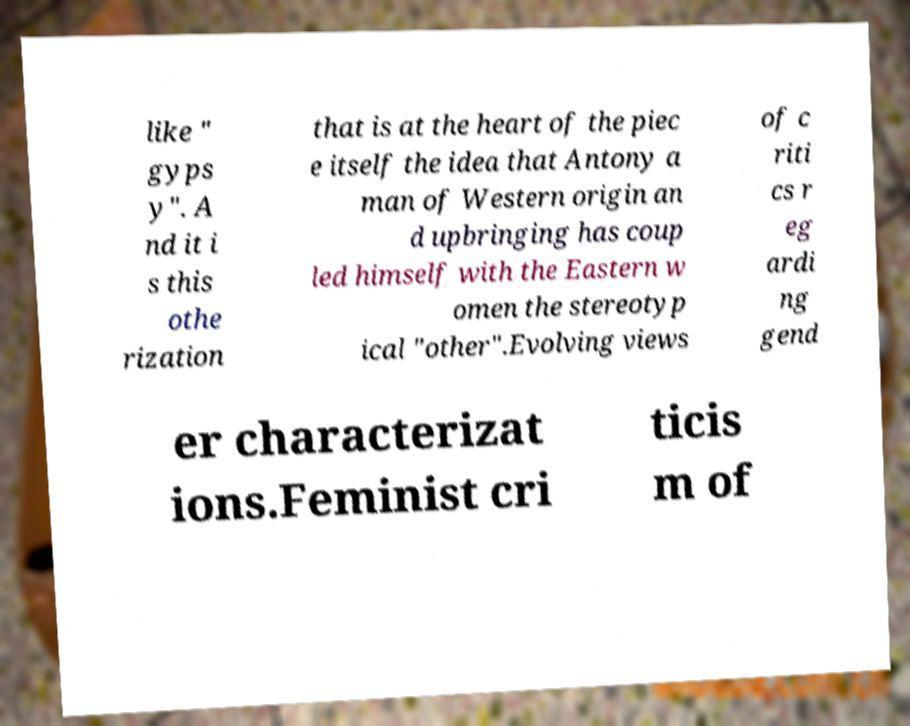Can you accurately transcribe the text from the provided image for me? like " gyps y". A nd it i s this othe rization that is at the heart of the piec e itself the idea that Antony a man of Western origin an d upbringing has coup led himself with the Eastern w omen the stereotyp ical "other".Evolving views of c riti cs r eg ardi ng gend er characterizat ions.Feminist cri ticis m of 